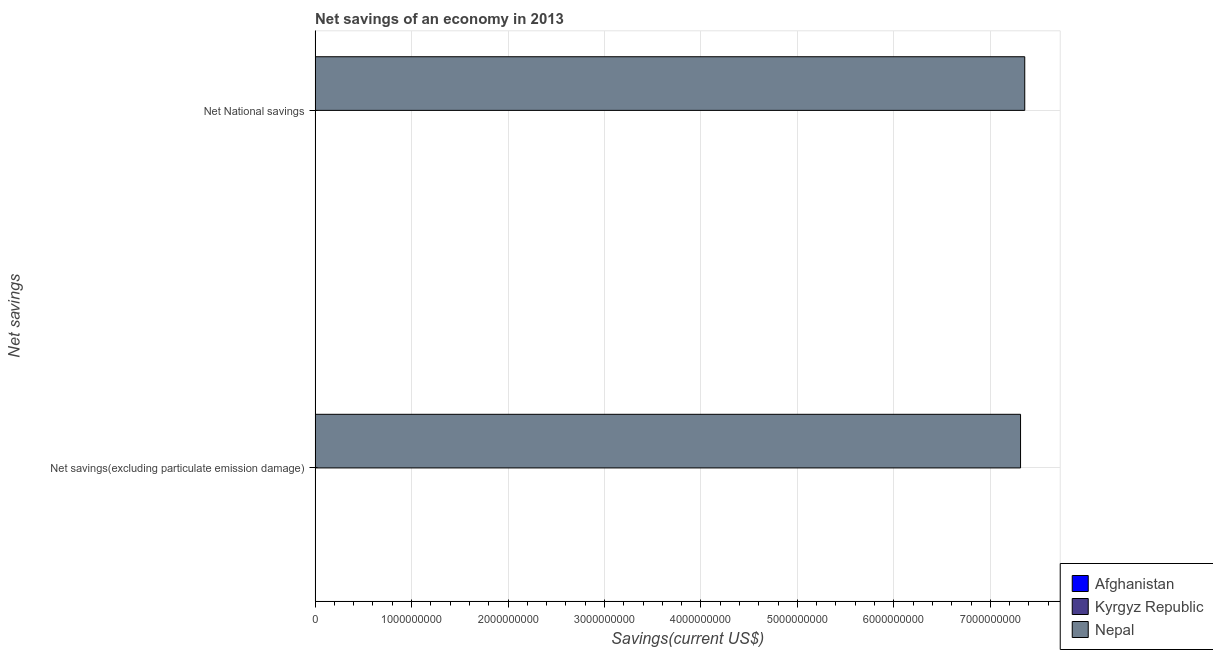Are the number of bars per tick equal to the number of legend labels?
Your answer should be compact. No. Are the number of bars on each tick of the Y-axis equal?
Offer a very short reply. Yes. What is the label of the 2nd group of bars from the top?
Your response must be concise. Net savings(excluding particulate emission damage). What is the net savings(excluding particulate emission damage) in Afghanistan?
Your answer should be compact. 0. Across all countries, what is the maximum net national savings?
Your answer should be compact. 7.36e+09. In which country was the net savings(excluding particulate emission damage) maximum?
Offer a terse response. Nepal. What is the total net national savings in the graph?
Keep it short and to the point. 7.36e+09. What is the difference between the net national savings in Nepal and the net savings(excluding particulate emission damage) in Afghanistan?
Ensure brevity in your answer.  7.36e+09. What is the average net national savings per country?
Offer a terse response. 2.45e+09. What is the difference between the net national savings and net savings(excluding particulate emission damage) in Nepal?
Provide a short and direct response. 4.36e+07. In how many countries, is the net national savings greater than 6800000000 US$?
Keep it short and to the point. 1. In how many countries, is the net national savings greater than the average net national savings taken over all countries?
Give a very brief answer. 1. How many bars are there?
Offer a terse response. 2. Are the values on the major ticks of X-axis written in scientific E-notation?
Provide a short and direct response. No. Does the graph contain grids?
Give a very brief answer. Yes. Where does the legend appear in the graph?
Make the answer very short. Bottom right. How many legend labels are there?
Your answer should be very brief. 3. What is the title of the graph?
Your response must be concise. Net savings of an economy in 2013. Does "Georgia" appear as one of the legend labels in the graph?
Give a very brief answer. No. What is the label or title of the X-axis?
Your answer should be very brief. Savings(current US$). What is the label or title of the Y-axis?
Make the answer very short. Net savings. What is the Savings(current US$) of Kyrgyz Republic in Net savings(excluding particulate emission damage)?
Ensure brevity in your answer.  0. What is the Savings(current US$) in Nepal in Net savings(excluding particulate emission damage)?
Provide a succinct answer. 7.31e+09. What is the Savings(current US$) of Afghanistan in Net National savings?
Ensure brevity in your answer.  0. What is the Savings(current US$) of Nepal in Net National savings?
Give a very brief answer. 7.36e+09. Across all Net savings, what is the maximum Savings(current US$) in Nepal?
Keep it short and to the point. 7.36e+09. Across all Net savings, what is the minimum Savings(current US$) of Nepal?
Your answer should be compact. 7.31e+09. What is the total Savings(current US$) of Kyrgyz Republic in the graph?
Your response must be concise. 0. What is the total Savings(current US$) of Nepal in the graph?
Keep it short and to the point. 1.47e+1. What is the difference between the Savings(current US$) in Nepal in Net savings(excluding particulate emission damage) and that in Net National savings?
Provide a short and direct response. -4.36e+07. What is the average Savings(current US$) of Afghanistan per Net savings?
Keep it short and to the point. 0. What is the average Savings(current US$) in Kyrgyz Republic per Net savings?
Your response must be concise. 0. What is the average Savings(current US$) in Nepal per Net savings?
Your answer should be compact. 7.34e+09. What is the difference between the highest and the second highest Savings(current US$) of Nepal?
Keep it short and to the point. 4.36e+07. What is the difference between the highest and the lowest Savings(current US$) of Nepal?
Ensure brevity in your answer.  4.36e+07. 